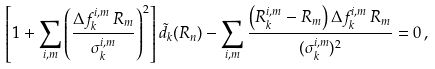Convert formula to latex. <formula><loc_0><loc_0><loc_500><loc_500>\left [ 1 + \sum _ { i , m } \left ( \frac { \Delta f _ { k } ^ { i , m } \, R _ { m } } { \sigma _ { k } ^ { i , m } } \right ) ^ { 2 } \right ] \tilde { d } _ { k } ( R _ { n } ) - \sum _ { i , m } \frac { \left ( R _ { k } ^ { i , m } - R _ { m } \right ) \Delta f _ { k } ^ { i , m } \, R _ { m } } { ( \sigma _ { k } ^ { i , m } ) ^ { 2 } } = 0 \, ,</formula> 